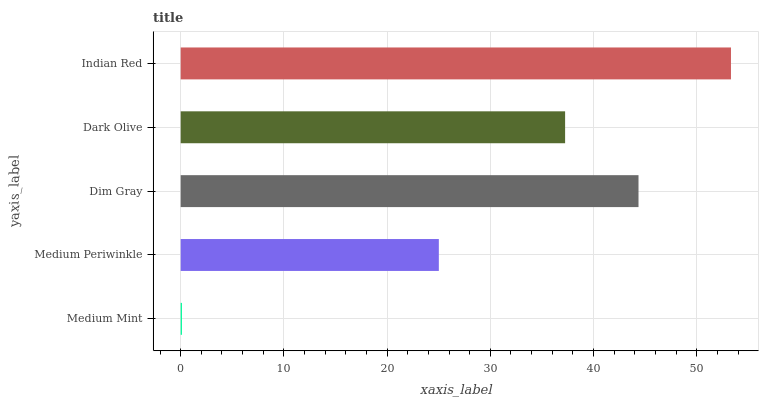Is Medium Mint the minimum?
Answer yes or no. Yes. Is Indian Red the maximum?
Answer yes or no. Yes. Is Medium Periwinkle the minimum?
Answer yes or no. No. Is Medium Periwinkle the maximum?
Answer yes or no. No. Is Medium Periwinkle greater than Medium Mint?
Answer yes or no. Yes. Is Medium Mint less than Medium Periwinkle?
Answer yes or no. Yes. Is Medium Mint greater than Medium Periwinkle?
Answer yes or no. No. Is Medium Periwinkle less than Medium Mint?
Answer yes or no. No. Is Dark Olive the high median?
Answer yes or no. Yes. Is Dark Olive the low median?
Answer yes or no. Yes. Is Medium Mint the high median?
Answer yes or no. No. Is Indian Red the low median?
Answer yes or no. No. 